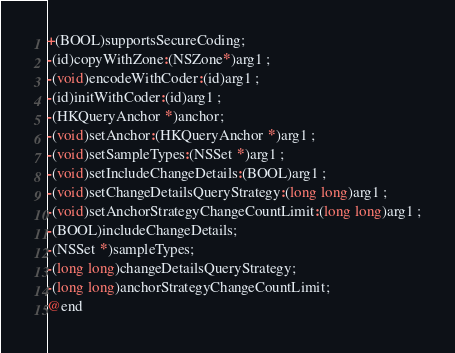Convert code to text. <code><loc_0><loc_0><loc_500><loc_500><_C_>+(BOOL)supportsSecureCoding;
-(id)copyWithZone:(NSZone*)arg1 ;
-(void)encodeWithCoder:(id)arg1 ;
-(id)initWithCoder:(id)arg1 ;
-(HKQueryAnchor *)anchor;
-(void)setAnchor:(HKQueryAnchor *)arg1 ;
-(void)setSampleTypes:(NSSet *)arg1 ;
-(void)setIncludeChangeDetails:(BOOL)arg1 ;
-(void)setChangeDetailsQueryStrategy:(long long)arg1 ;
-(void)setAnchorStrategyChangeCountLimit:(long long)arg1 ;
-(BOOL)includeChangeDetails;
-(NSSet *)sampleTypes;
-(long long)changeDetailsQueryStrategy;
-(long long)anchorStrategyChangeCountLimit;
@end

</code> 